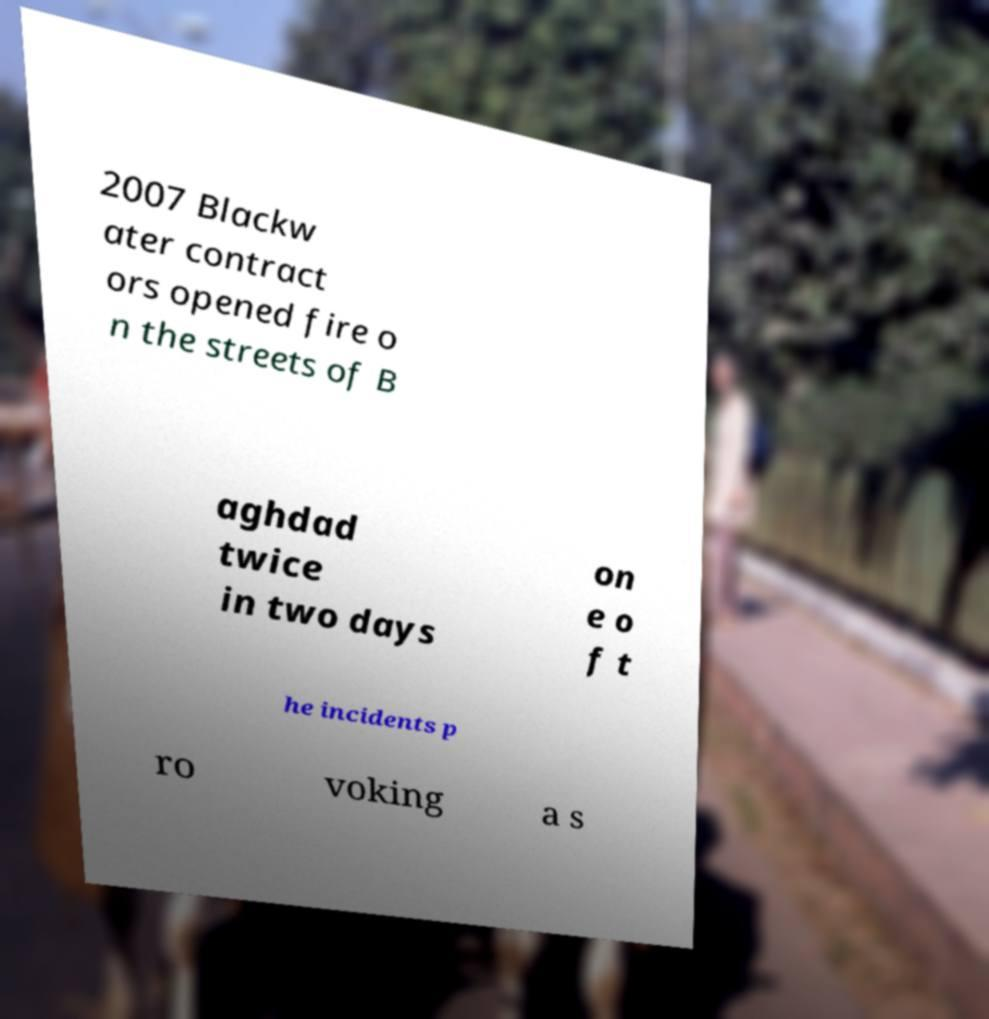Please read and relay the text visible in this image. What does it say? 2007 Blackw ater contract ors opened fire o n the streets of B aghdad twice in two days on e o f t he incidents p ro voking a s 